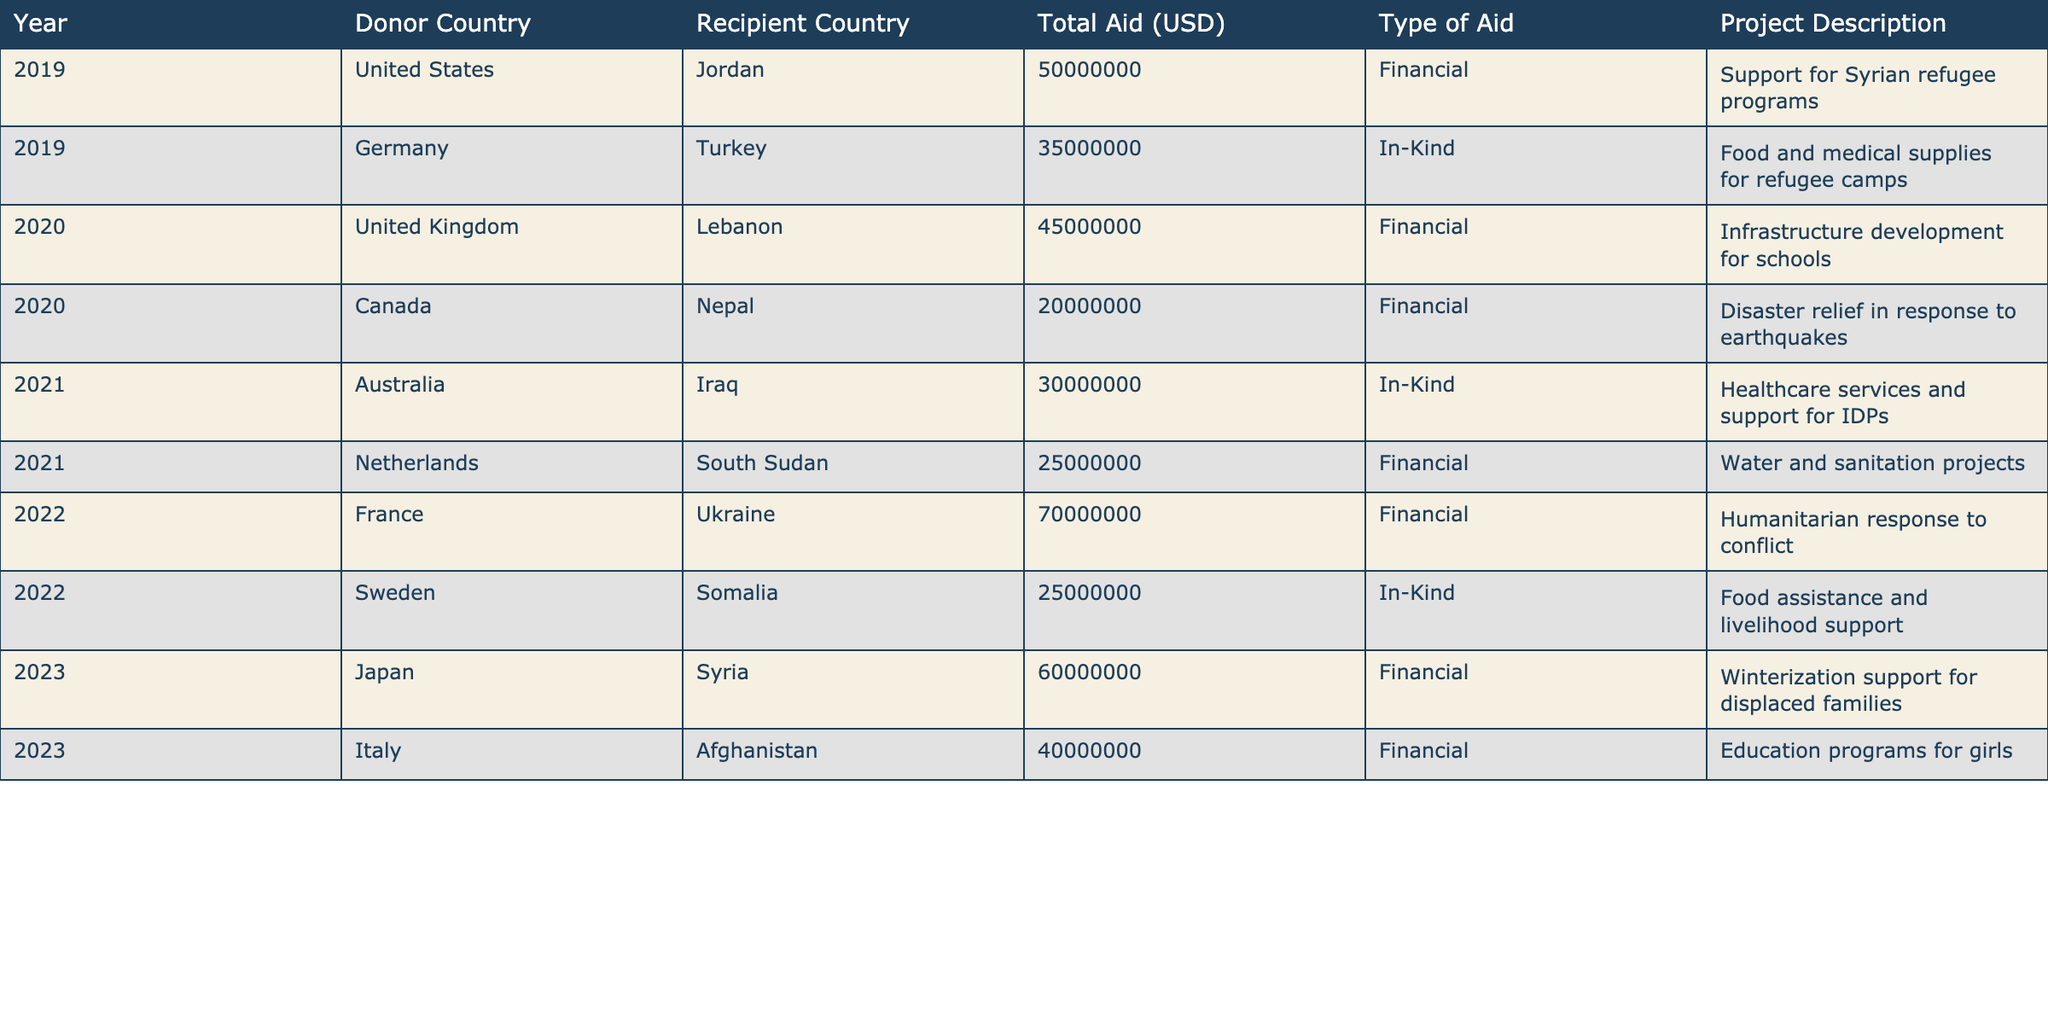What was the total aid received by Country A in 2019? According to the table, the total aid received by Jordan (Country A) in 2019 from the United States was 50 million USD.
Answer: 50 million USD Which year saw the highest total aid to Country A? By analyzing the table, we can see that in 2022, Ukraine received 70 million USD, which is the highest amount recorded. However, the data does not record aid specifically to Country A, which is Jordan. Since this was not applicable, I would conclude that there is a lack of data for Country A to determine the highest.
Answer: No applicable data available How much financial aid did Country A receive compared to in-kind aid over the past five years? Jordan received a total of 50 million USD as financial aid in 2019 and 60 million USD as financial aid in 2023, making it 110 million USD in total for financial aid. There was no in-kind aid recorded for Jordan.
Answer: 110 million USD financial aid, 0 USD in-kind aid Did any donor country provide aid to Country A in more than one type? The table does not list any instances where a single donor provided both financial and in-kind aid to a single recipient country, specifically Jordan. Therefore, the answer is no.
Answer: No What is the average amount of aid received by Country A per year? The total financial aid received by Jordan over the years mentioned is 110 million USD (50 million in 2019 and 60 million in 2023), averaged over the two years of aid, which gives (50 + 60) / 2 = 55 million USD.
Answer: 55 million USD 